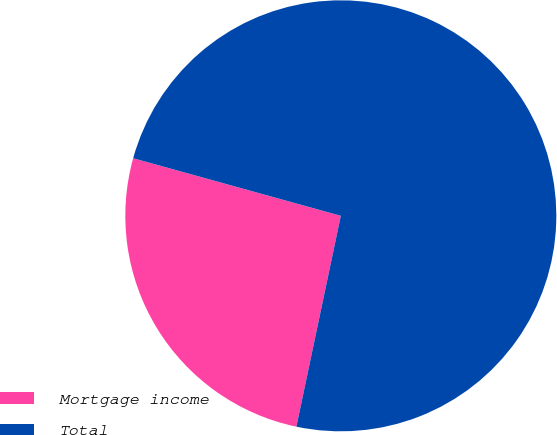Convert chart to OTSL. <chart><loc_0><loc_0><loc_500><loc_500><pie_chart><fcel>Mortgage income<fcel>Total<nl><fcel>26.0%<fcel>74.0%<nl></chart> 